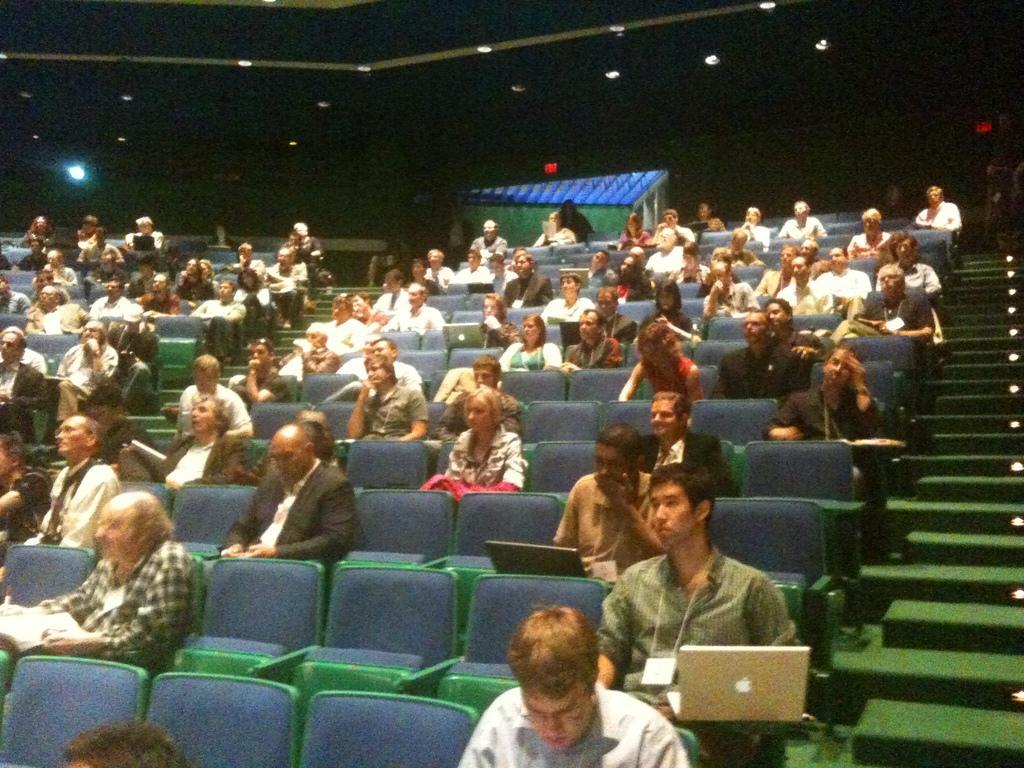Describe this image in one or two sentences. In the picture we can see many people are sitting on the chairs and holding laptops and beside them, we can see the steps and lights to it and to the ceiling we can see the lights in the dark. 